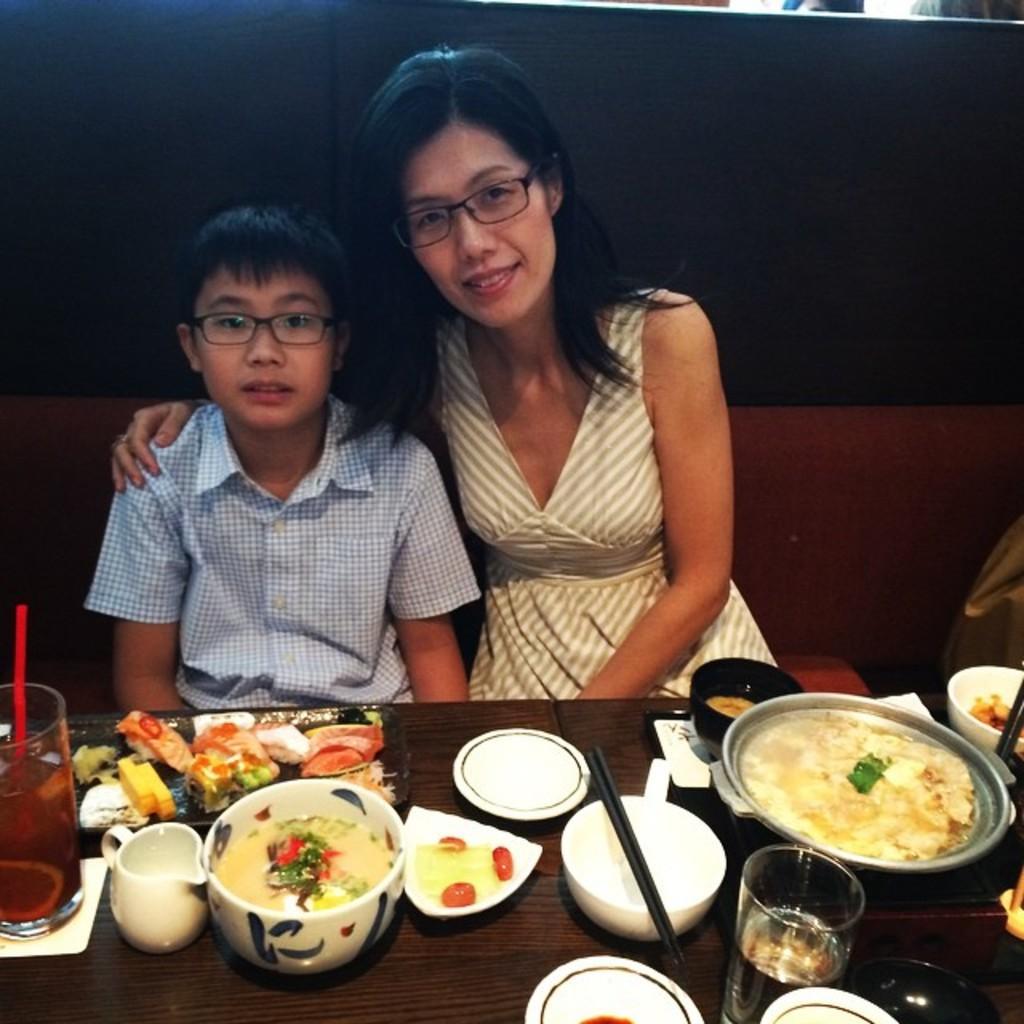In one or two sentences, can you explain what this image depicts? In this picture I can see two people are sitting on the couch in front of the table, on which I can see some food items are placed. 